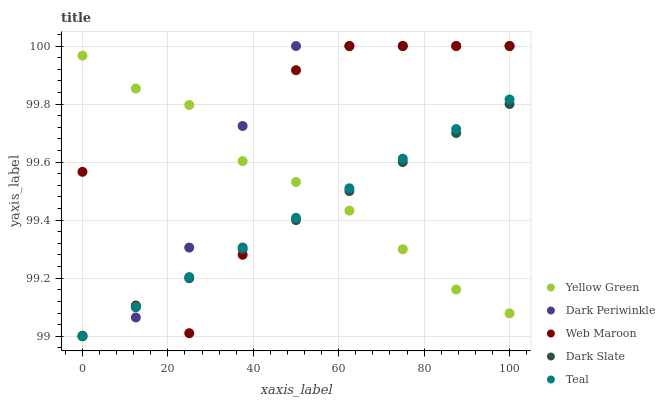Does Dark Slate have the minimum area under the curve?
Answer yes or no. Yes. Does Dark Periwinkle have the maximum area under the curve?
Answer yes or no. Yes. Does Web Maroon have the minimum area under the curve?
Answer yes or no. No. Does Web Maroon have the maximum area under the curve?
Answer yes or no. No. Is Teal the smoothest?
Answer yes or no. Yes. Is Web Maroon the roughest?
Answer yes or no. Yes. Is Yellow Green the smoothest?
Answer yes or no. No. Is Yellow Green the roughest?
Answer yes or no. No. Does Dark Slate have the lowest value?
Answer yes or no. Yes. Does Web Maroon have the lowest value?
Answer yes or no. No. Does Dark Periwinkle have the highest value?
Answer yes or no. Yes. Does Yellow Green have the highest value?
Answer yes or no. No. Does Teal intersect Web Maroon?
Answer yes or no. Yes. Is Teal less than Web Maroon?
Answer yes or no. No. Is Teal greater than Web Maroon?
Answer yes or no. No. 